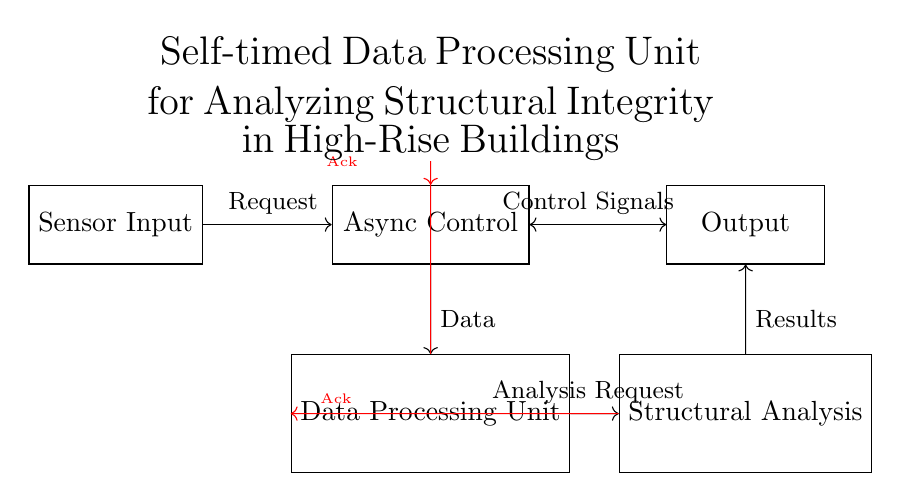What is the name of the control module? The control module is labeled as "Async Control" in the diagram.
Answer: Async Control What type of signals are represented in red? The red signals in the diagram represent acknowledgment signals that indicate the completion of a task.
Answer: Acknowledgment signals How many main units are in the circuit diagram? There are four main units illustrated in the circuit diagram: Sensor Input, Async Control, Data Processing Unit, and Structural Analysis.
Answer: Four What is the purpose of the Data Processing Unit? The Data Processing Unit is designed to process data received from the sensors before analysis can occur.
Answer: Data Processing What connections exist between the Async Control and the Output? There is a bidirectional connection between Async Control and Output, which allows for control signals and feedback to flow both ways.
Answer: Bidirectional connection What is the function of the Structural Analysis module? The Structural Analysis module is responsible for analyzing the data processed by the Data Processing Unit to assess structural integrity.
Answer: Analyzing structural integrity What type of processing system is used in the circuit? The processing system used is asynchronous, allowing for operations without a synchronized clock signal.
Answer: Asynchronous 